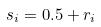Convert formula to latex. <formula><loc_0><loc_0><loc_500><loc_500>s _ { i } = 0 . 5 + r _ { i }</formula> 